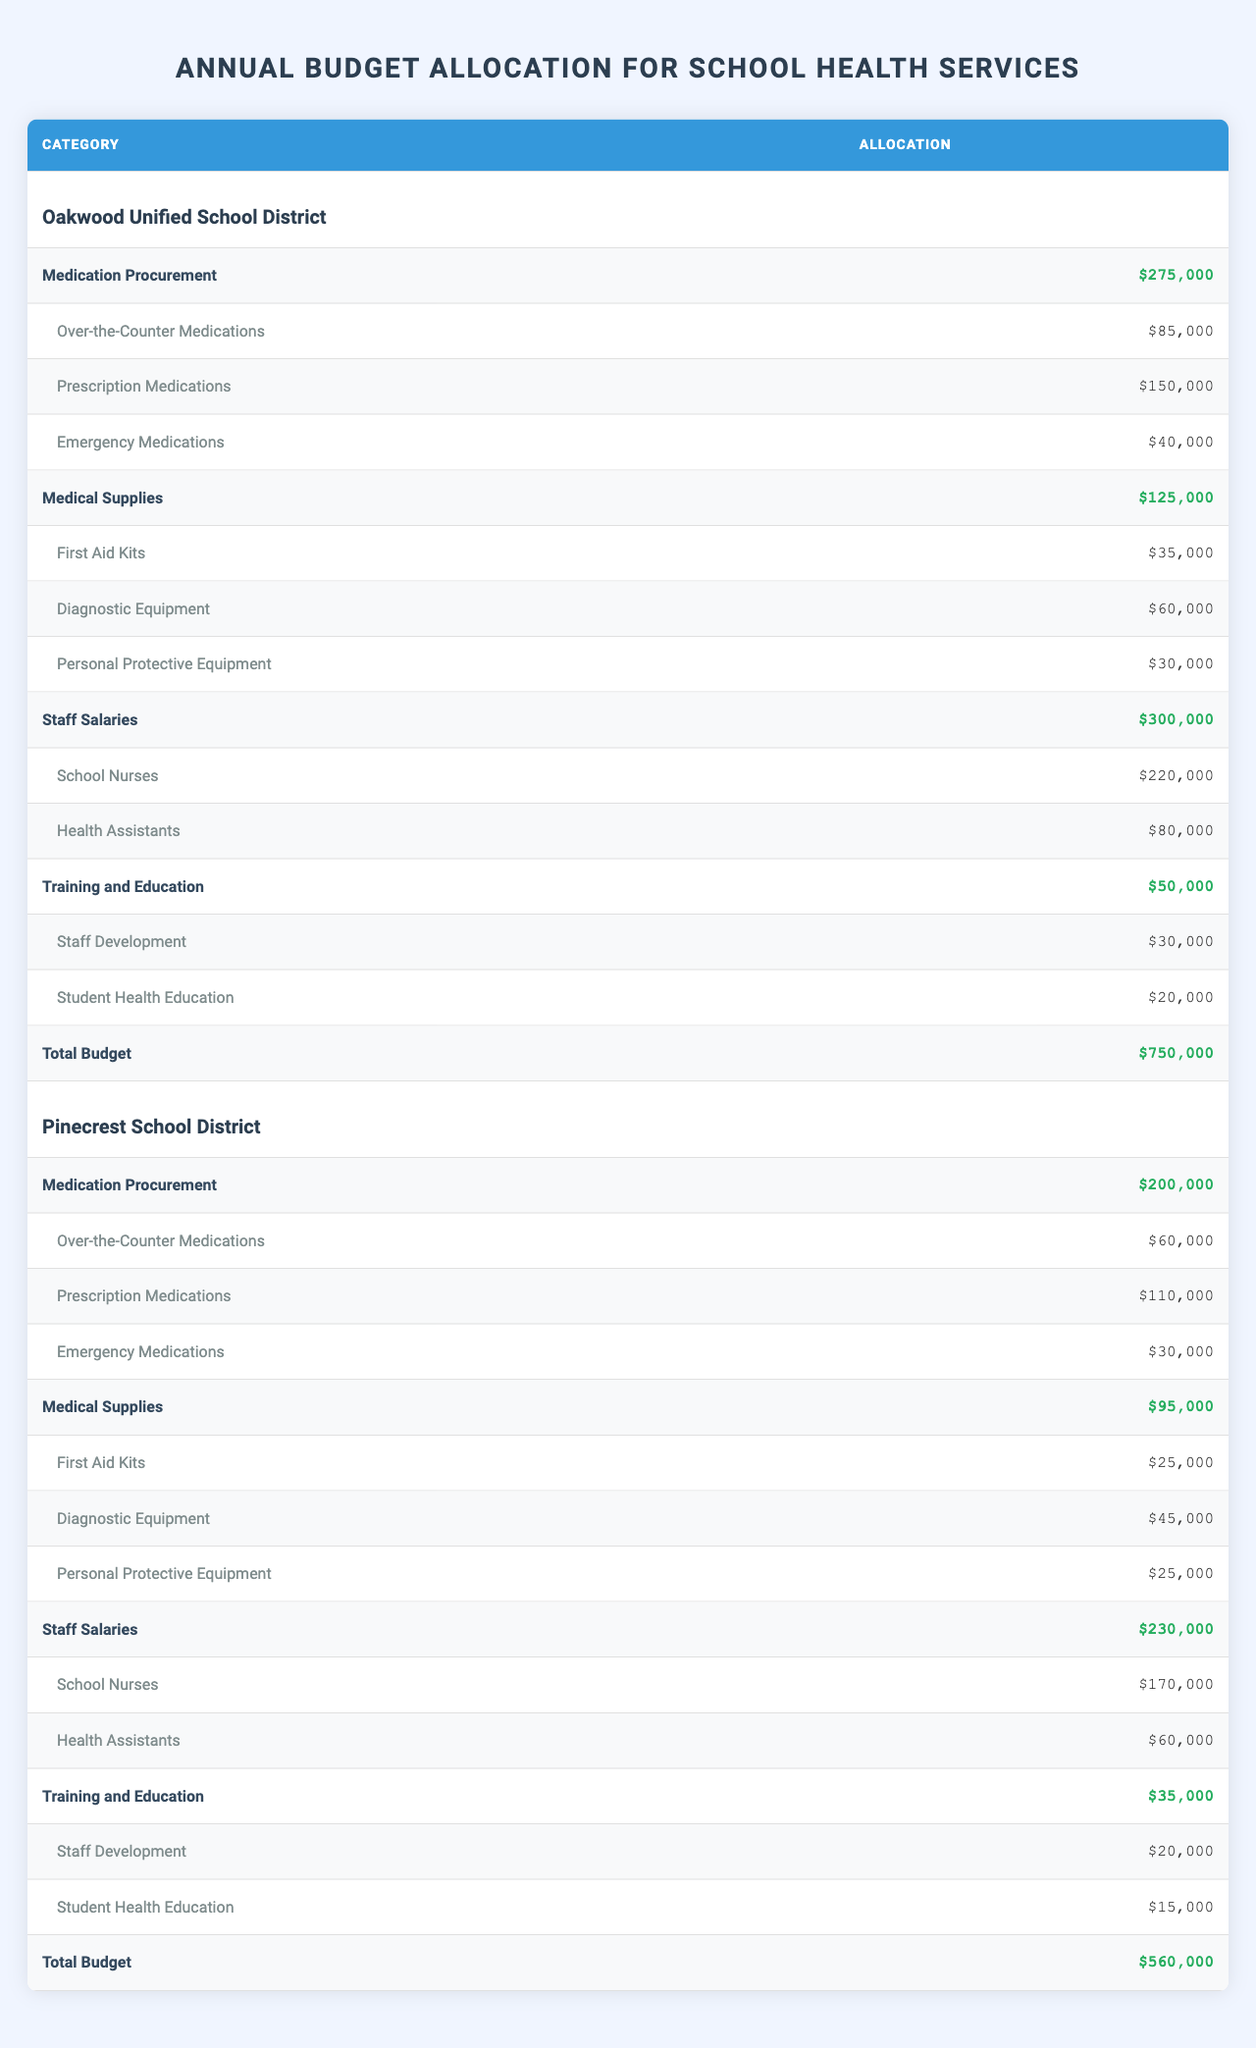What is the total allocation for medication procurement in Oakwood Unified School District? According to the table, the total allocation for medication procurement in Oakwood Unified School District is $275,000, as specified in the "Medication Procurement" category.
Answer: $275,000 How much is allocated for emergency medications in Pinecrest School District? In Pinecrest School District, the allocation for emergency medications is listed under the "Medication Procurement" category, totaling $30,000.
Answer: $30,000 Which district has a higher total budget? Oakwood Unified School District has a total budget of $750,000 while Pinecrest School District has a total budget of $560,000. Since 750,000 > 560,000, Oakwood has the higher total budget.
Answer: Oakwood Unified School District What is the combined amount allocated for staff salaries in both districts? For Oakwood Unified, the staff salaries allocation is $300,000 and for Pinecrest, it is $230,000. Adding these amounts gives $300,000 + $230,000 = $530,000 as the combined total.
Answer: $530,000 Are more funds allocated for first aid kits in Oakwood Unified School District compared to Pinecrest School District? Oakwood has allocated $35,000 for first aid kits while Pinecrest has allocated $25,000. Since 35,000 > 25,000, more funds are indeed allocated for first aid kits in Oakwood.
Answer: Yes What is the percentage of the total budget that is allocated to training and education in Pinecrest School District? The total budget for Pinecrest School District is $560,000 and the allocation for training and education is $35,000. To find the percentage, calculate (35,000 / 560,000) * 100 = 6.25%.
Answer: 6.25% Which subcategory under medication procurement has the highest allocation in Oakwood Unified School District? In the "Medication Procurement" category for Oakwood, the subcategories are Over-the-Counter Medications ($85,000), Prescription Medications ($150,000), and Emergency Medications ($40,000). The highest allocation among these is for Prescription Medications at $150,000.
Answer: Prescription Medications What is the difference between the total budget of Oakwood Unified School District and Pinecrest School District? To find the difference, subtract the total budget of Pinecrest ($560,000) from that of Oakwood ($750,000), which gives $750,000 - $560,000 = $190,000.
Answer: $190,000 How much is allocated for health assistants in Oakwood Unified School District compared to Pinecrest School District? In Oakwood, $80,000 is allocated for health assistants while Pinecrest allocates $60,000. The amount in Oakwood is greater as $80,000 > $60,000.
Answer: Oakwood has more allocation What is the total allocation for medical supplies in both districts? Oakwood has $125,000 allocated for medical supplies and Pinecrest has $95,000. Adding these gives $125,000 + $95,000 = $220,000 for both districts.
Answer: $220,000 